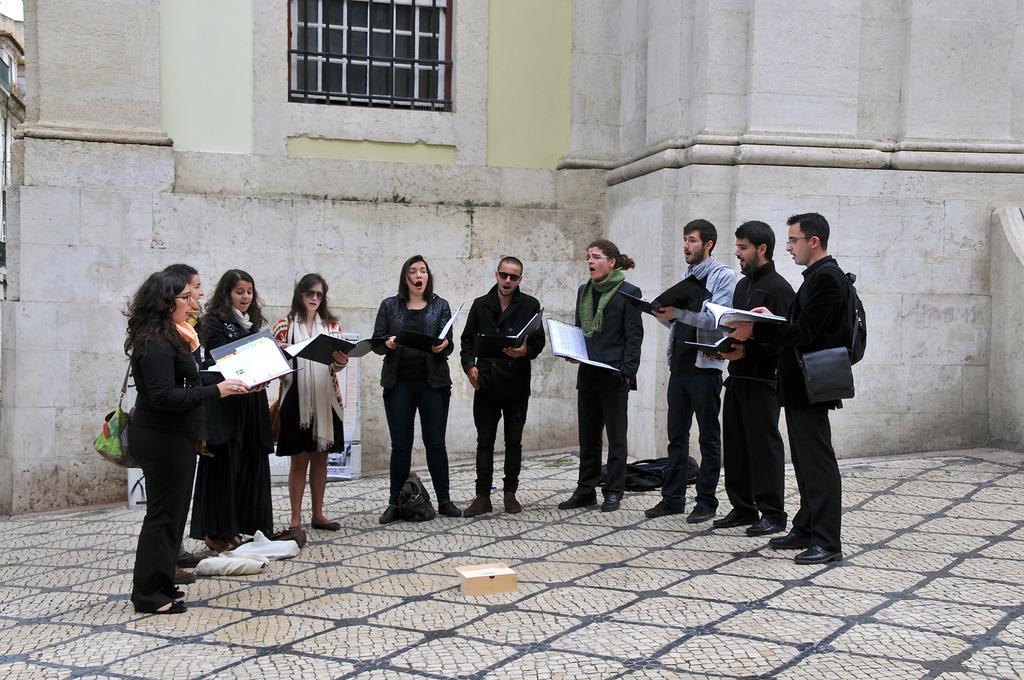How would you summarize this image in a sentence or two? There are some people standing and singing. And they are holding book. Some are holding bag. On the ground there are bags. In the background there is a building with window. 